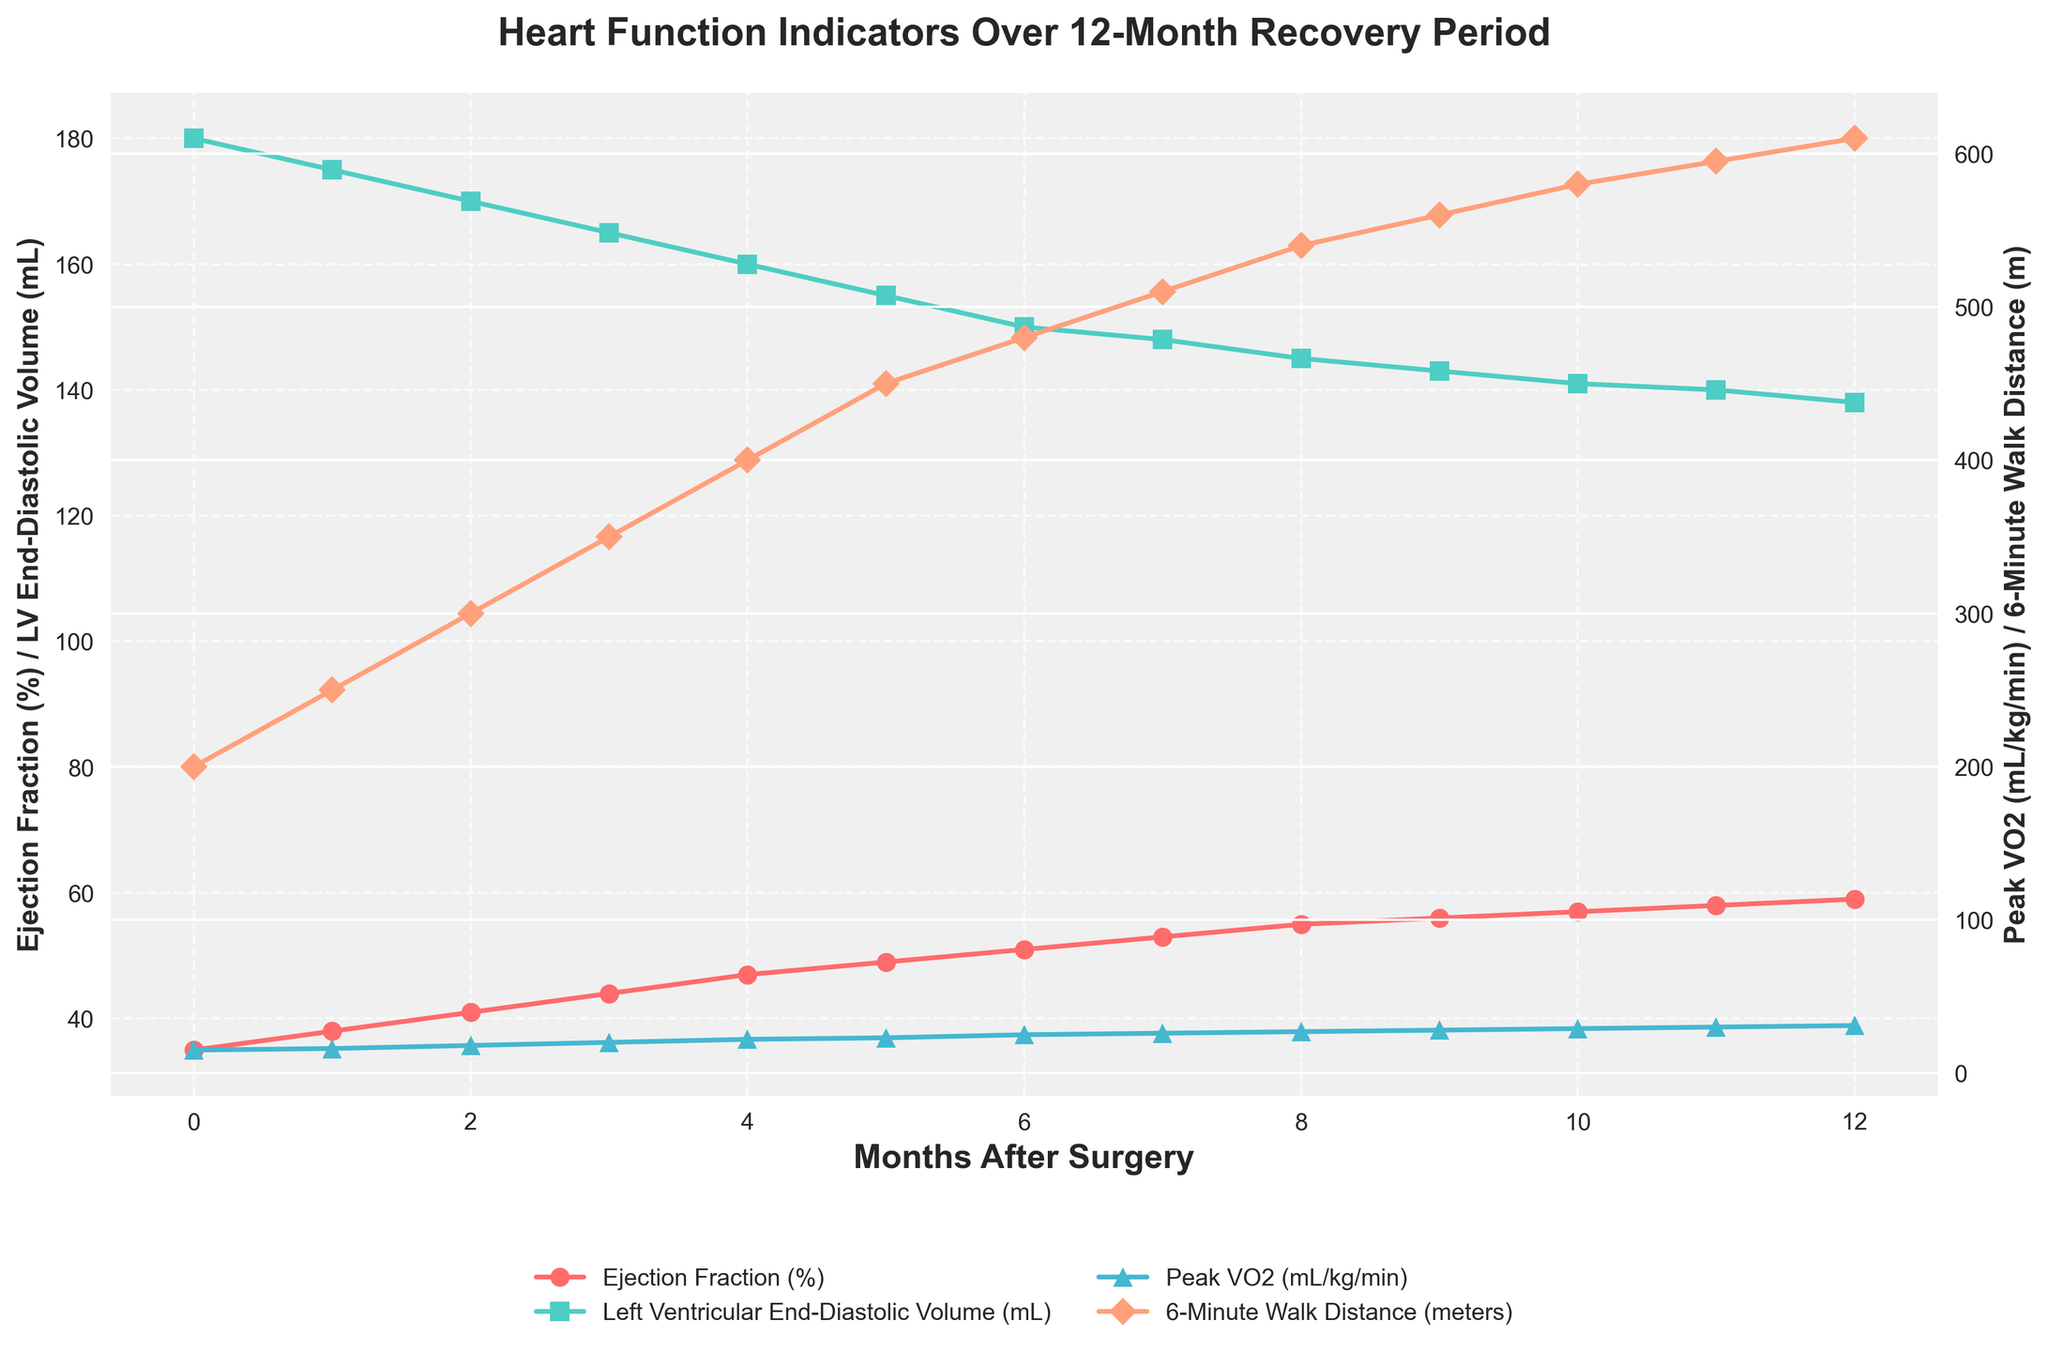What is the trend in the Ejection Fraction (%) from the surgery month to month 6? To find the trend, observe the plot line for Ejection Fraction. From month 0 to month 6, the Ejection Fraction increases steadily from 35% to 51%.
Answer: Increasing At which month does the 6-Minute Walk Distance (meters) first reach or exceed 500 meters? To find out when the 6-Minute Walk Distance first reaches or exceeds 500 meters, look at the plot line for this indicator. The line reaches 510 meters at month 7.
Answer: Month 7 Which month shows the highest Peak VO2 (mL/kg/min)? To identify the peak month for Peak VO2, find the highest point on the corresponding line. The highest point is 31 at month 12.
Answer: Month 12 Compare the Ejection Fraction (%) and Left Ventricular End-Diastolic Volume (mL) at month 3. Which one shows a greater increase from the previous month? Check month 3 for both indicators. The Ejection Fraction increases from 41% to 44%, a 3% rise, while the LV End-Diastolic Volume decreases from 170 mL to 165 mL, a 5 mL decrease.
Answer: Ejection Fraction What's the difference in the 6-Minute Walk Distance (meters) between month 4 and month 8? Check the plot lines at month 4 and month 8. The distances are 400 meters and 540 meters respectively. The difference is 540 - 400 = 140 meters.
Answer: 140 meters What is the average Ejection Fraction (%) during the first six months? Calculate the average of the Ejection Fraction values for the first six months: (35 + 38 + 41 + 44 + 47 + 49)/6. The sum is 254, and the average is 254/6 ≈ 42.33%.
Answer: 42.33% Which indicator shows the most consistent increase over the 12-month period? To determine this, observe the consistency of the trend lines. The Ejection Fraction shows a steady and consistent increase over all 12 months.
Answer: Ejection Fraction How does the Left Ventricular End-Diastolic Volume change over the 12-month period? Observe the plot line for the Left Ventricular End-Diastolic Volume. It decreases from 180 mL to 138 mL over the 12 months, showing a downward trend.
Answer: Decreasing Compare the Peak VO2 (mL/kg/min) at month 6 and month 12. How much did it increase? Look at the plot line values for Peak VO2 at month 6 and month 12. The values are 25 and 31 respectively. The increase is 31 - 25 = 6 mL/kg/min.
Answer: 6 mL/kg/min What month has the largest single-month increase in the Ejection Fraction (%)? Check the Ejection Fraction change between consecutive months. The largest increase is from month 3 to month 4, going from 44% to 47%, which is a 3% increase.
Answer: Month 4 